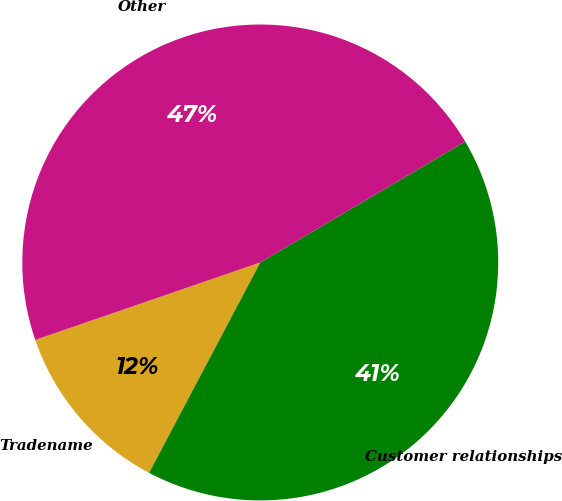<chart> <loc_0><loc_0><loc_500><loc_500><pie_chart><fcel>Tradename<fcel>Customer relationships<fcel>Other<nl><fcel>11.99%<fcel>41.22%<fcel>46.79%<nl></chart> 